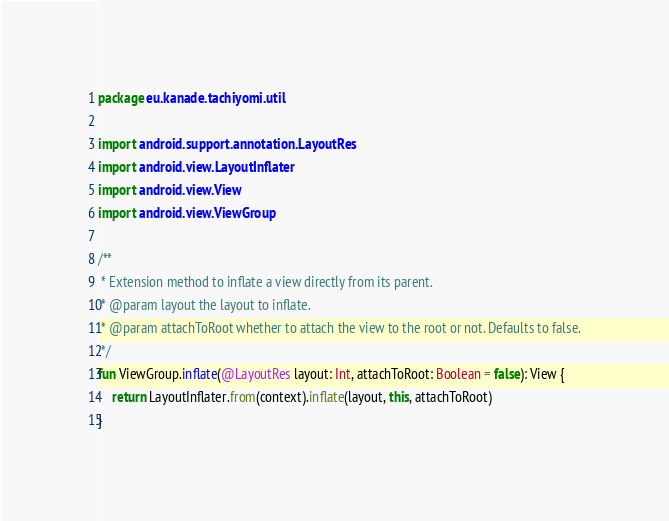<code> <loc_0><loc_0><loc_500><loc_500><_Kotlin_>package eu.kanade.tachiyomi.util

import android.support.annotation.LayoutRes
import android.view.LayoutInflater
import android.view.View
import android.view.ViewGroup

/**
 * Extension method to inflate a view directly from its parent.
 * @param layout the layout to inflate.
 * @param attachToRoot whether to attach the view to the root or not. Defaults to false.
 */
fun ViewGroup.inflate(@LayoutRes layout: Int, attachToRoot: Boolean = false): View {
    return LayoutInflater.from(context).inflate(layout, this, attachToRoot)
}
</code> 